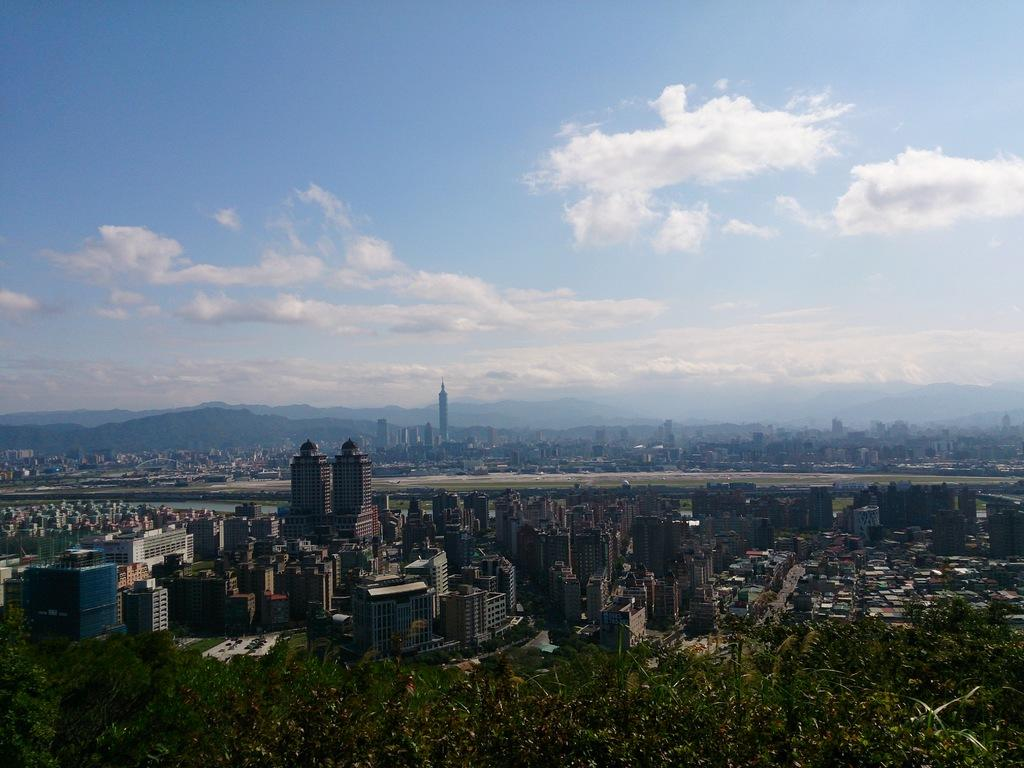What type of structures can be seen in the image? There are buildings in the image. What natural elements are present in the image? There are trees in the image. Can you describe any other objects or features in the image? There are other unspecified things in the image. What can be seen in the background of the image? There are mountains and the sky visible in the background of the image. How do the lizards show respect to the trees in the image? There are no lizards present in the image, so it is not possible to answer that question. 